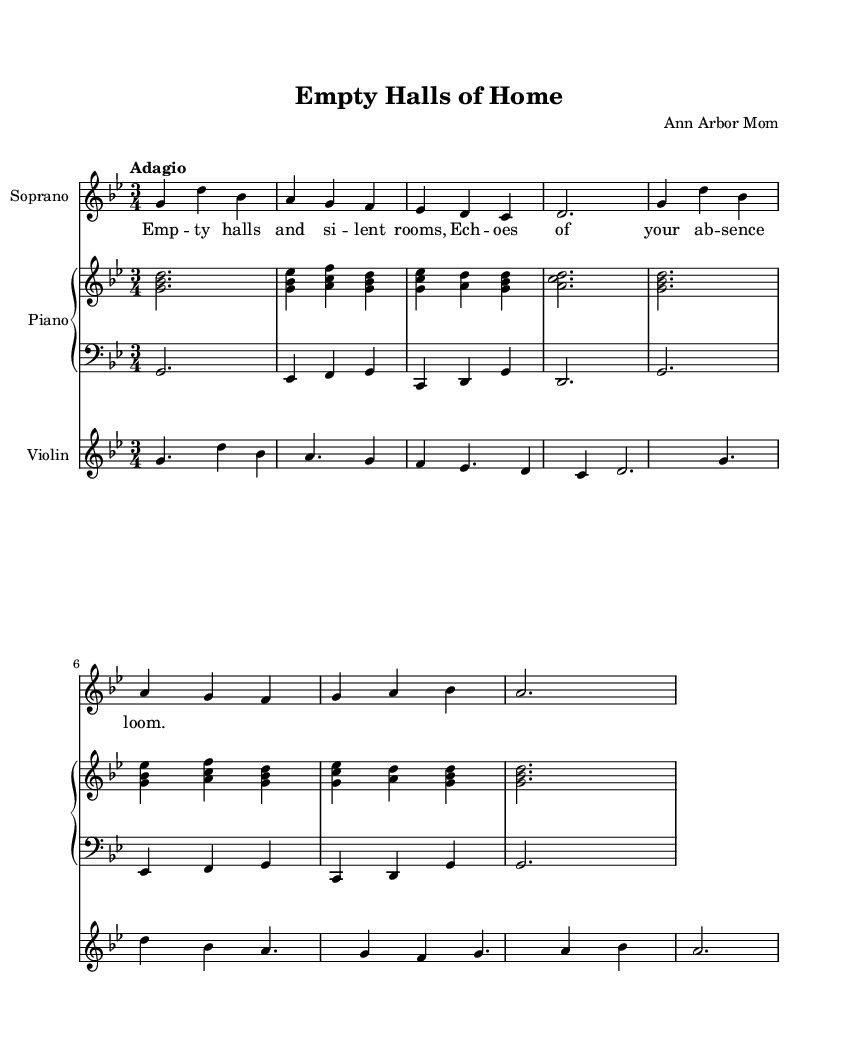What is the key signature of this music? The key signature is G minor, which has two flats (B flat and E flat). This is indicated at the beginning of the sheet music before the staff.
Answer: G minor What is the time signature of this music? The time signature is 3/4, meaning there are three beats in each measure, and the quarter note gets one beat. This is found next to the key signature at the beginning of the piece.
Answer: 3/4 What is the tempo marking for this piece? The tempo marking is "Adagio," which indicates that the music should be played slowly and at a leisurely pace. This is specified above the staff at the beginning of the score.
Answer: Adagio How many measures are there in the Soprano part? There are 8 measures in the Soprano part, which can be counted by looking at the section and identifying the bars separated by vertical lines.
Answer: 8 What is the primary emotion conveyed in the lyrics of the piece? The primary emotion conveyed is sadness or longing, indicated by the lyrics reflecting themes of emptiness and absence. This is evident in the text provided beneath the Soprano part.
Answer: Sadness Which instruments are featured in this score? The instruments featured are Soprano, Piano, and Violin, as indicated by the labels at the beginning of each staff.
Answer: Soprano, Piano, Violin What harmony is used in the piano right hand? The harmony in the piano right hand alternates predominantly between major and minor chords and includes combinations such as G, B flat, and D. This can be analyzed by looking at the chord notations in that staff.
Answer: G, B flat, D 